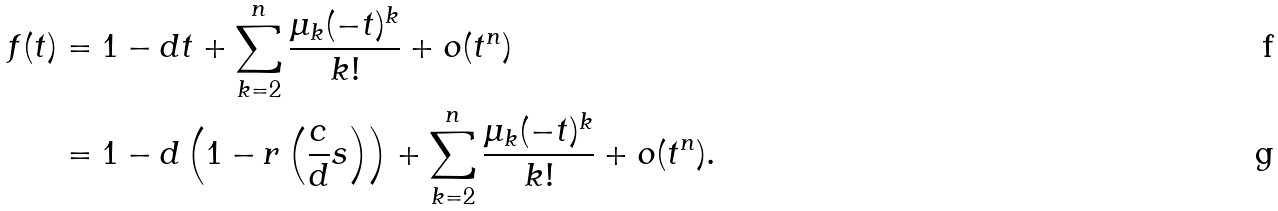Convert formula to latex. <formula><loc_0><loc_0><loc_500><loc_500>f ( t ) & = 1 - d t + \sum _ { k = 2 } ^ { n } \frac { \mu _ { k } ( - t ) ^ { k } } { k ! } + o ( t ^ { n } ) \\ & = 1 - d \left ( 1 - r \left ( \frac { c } { d } s \right ) \right ) + \sum _ { k = 2 } ^ { n } \frac { \mu _ { k } ( - t ) ^ { k } } { k ! } + o ( t ^ { n } ) .</formula> 